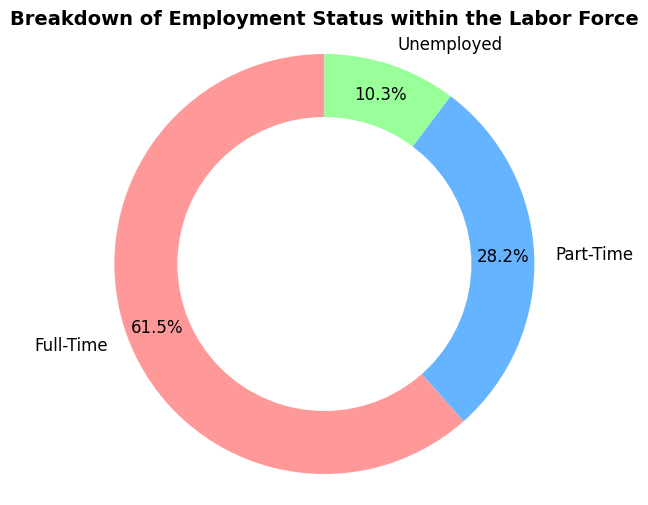What percentage of the labor force is employed full-time? The figure shows that the "Full-Time" section of the pie chart is labeled with its percentage. According to the chart, the percentage of people who are employed full-time is displayed directly.
Answer: 60.0% How does the number of part-time workers compare to the number of unemployed individuals? The figure indicates that there are 22,000 part-time workers and 8,000 unemployed individuals. By comparing these numbers, it can be seen that the number of part-time workers is greater than the number of unemployed individuals.
Answer: Part-time workers are greater Which employment status has the smallest portion of the pie chart? The pie chart visually represents the proportions of each employment status. The smallest segment can be identified by observing the chart, which corresponds to the "Unemployed" category.
Answer: Unemployed What is the total number of people represented in the chart? To find the total number of people, sum the values from all sections of the pie chart: 48,000 (Full-Time) + 22,000 (Part-Time) + 8,000 (Unemployed). The sum gives the total number of people.
Answer: 78,000 What is the difference in the number of people between full-time and part-time employment? The number of people employed full-time is 48,000, while the number of part-time workers is 22,000. The difference can be calculated by subtracting the part-time number from the full-time number: 48,000 - 22,000.
Answer: 26,000 What color represents the full-time employment status in the chart? The figure assigns specific colors to each employment status. By visually inspecting the pie chart, the color corresponding to the "Full-Time" section can be identified as red.
Answer: Red If you combine the number of part-time workers and unemployed people, what percentage of the labor force does that constitute? To determine the combined percentage, sum the number of part-time workers (22,000) and unemployed people (8,000) to get 30,000. Calculate the percentage by dividing this sum by the total number of people (78,000) and multiplying by 100: (30,000 / 78,000) * 100.
Answer: 38.5% Which is larger, the number of people employed full-time or the combined number of part-time and unemployed individuals? The number of people employed full-time is 48,000. The combined number of part-time and unemployed individuals is 22,000 + 8,000 = 30,000. By comparing these two values, it is evident that the number of people employed full-time is larger.
Answer: Full-time Is the percentage of full-time workers more than double the percentage of unemployed individuals? The percentage of full-time workers is 60.0%, and the percentage of unemployed individuals is 10.3%. To check if 60.0% is more than double 10.3%, calculate double the percentage of unemployed individuals, which is 10.3% * 2 = 20.6%. Since 60.0% is greater than 20.6%, the percentage of full-time workers is indeed more than double the percentage of unemployed individuals.
Answer: Yes What proportion of the labor force is not employed full-time? To find the proportion of the labor force that is not employed full-time, sum the percentages of the part-time and unemployed categories. According to the chart, the part-time percentage is 28.2% and the unemployed percentage is 10.3%. The total proportion not employed full-time is 28.2% + 10.3%.
Answer: 38.5% 